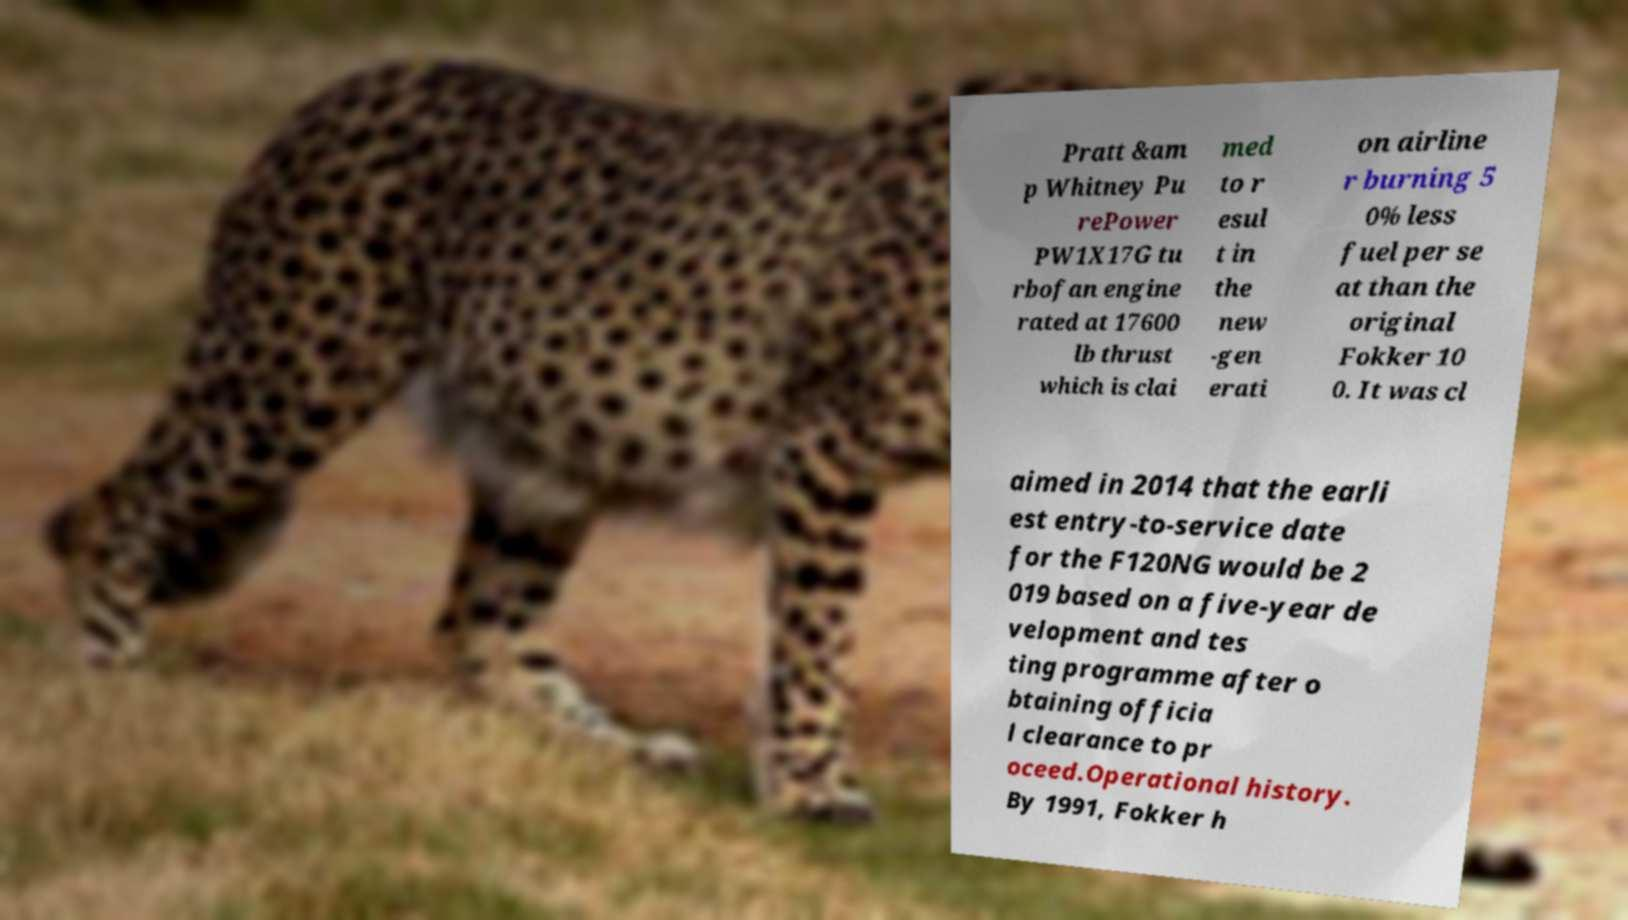Please identify and transcribe the text found in this image. Pratt &am p Whitney Pu rePower PW1X17G tu rbofan engine rated at 17600 lb thrust which is clai med to r esul t in the new -gen erati on airline r burning 5 0% less fuel per se at than the original Fokker 10 0. It was cl aimed in 2014 that the earli est entry-to-service date for the F120NG would be 2 019 based on a five-year de velopment and tes ting programme after o btaining officia l clearance to pr oceed.Operational history. By 1991, Fokker h 